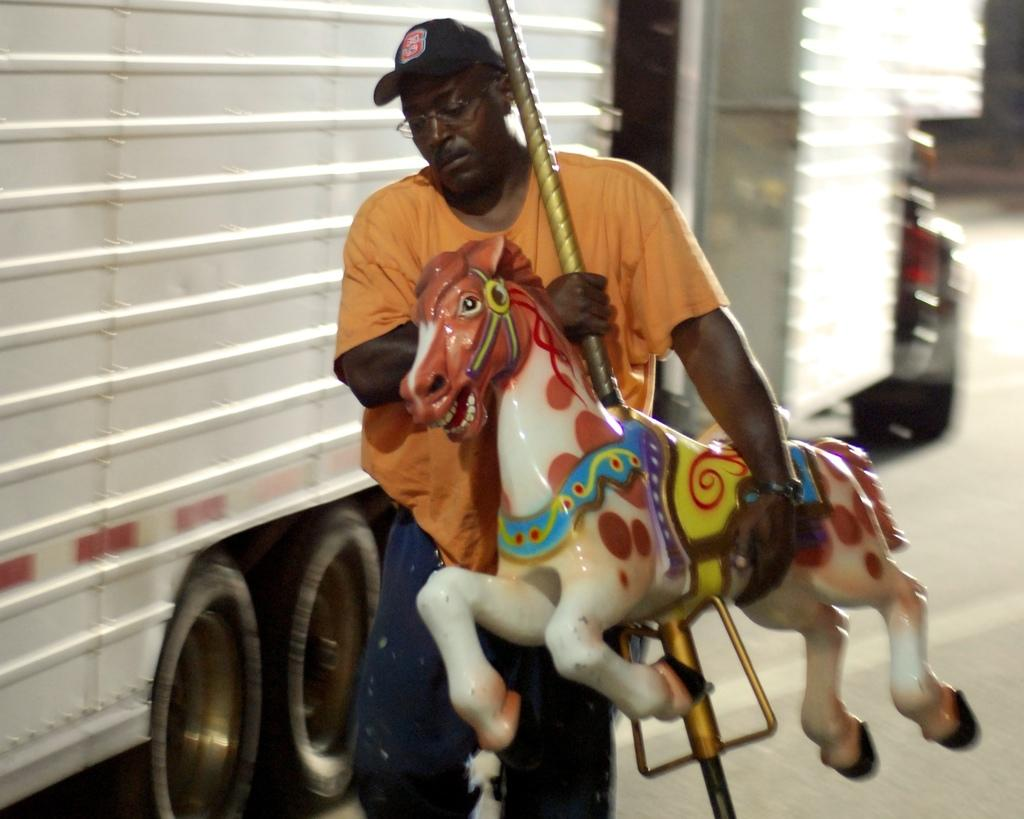Who is present in the image? There is a man in the image. What is the man holding in the image? The man is holding a toy horse. What is the man doing in the image? The man is walking. What can be seen in the background of the image? There is a vehicle and a door in the background of the image. Are there any cobwebs visible in the image? There is no mention of cobwebs in the provided facts, so we cannot determine if any are present in the image. 